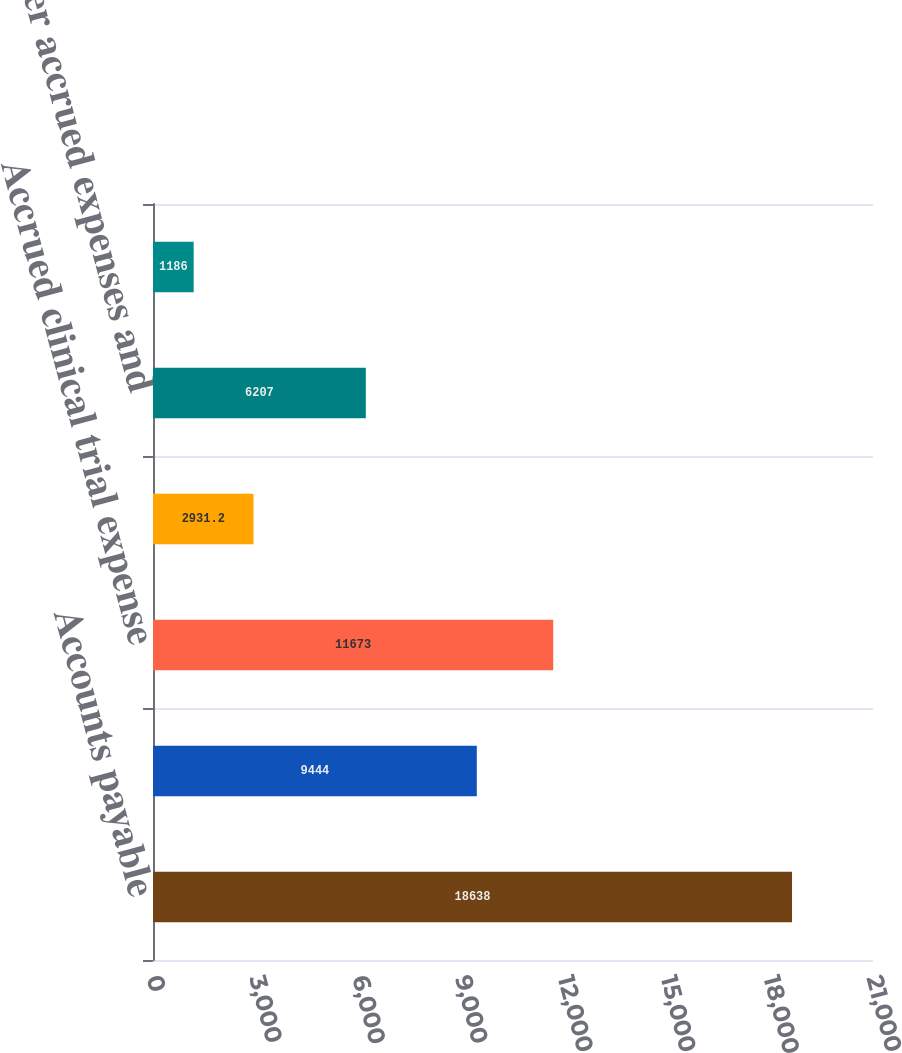<chart> <loc_0><loc_0><loc_500><loc_500><bar_chart><fcel>Accounts payable<fcel>Accrued payroll and related<fcel>Accrued clinical trial expense<fcel>Accrued property plant and<fcel>Other accrued expenses and<fcel>Payable to Bayer HealthCare<nl><fcel>18638<fcel>9444<fcel>11673<fcel>2931.2<fcel>6207<fcel>1186<nl></chart> 